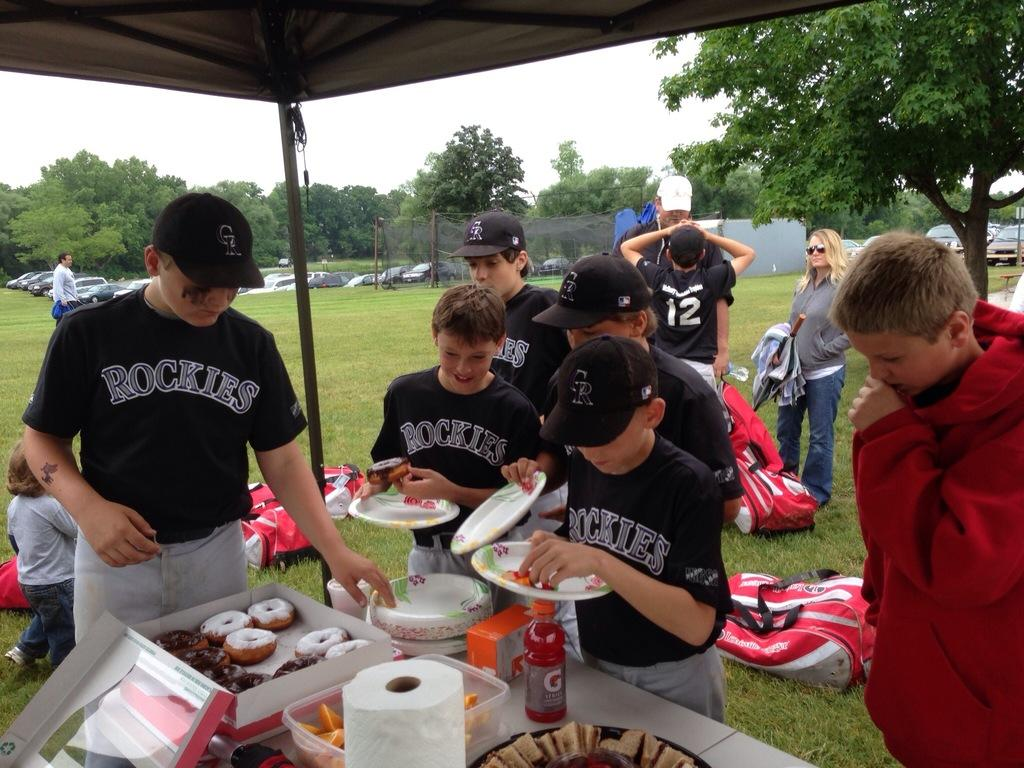<image>
Write a terse but informative summary of the picture. a Rockies player that is next to a box of donuts 